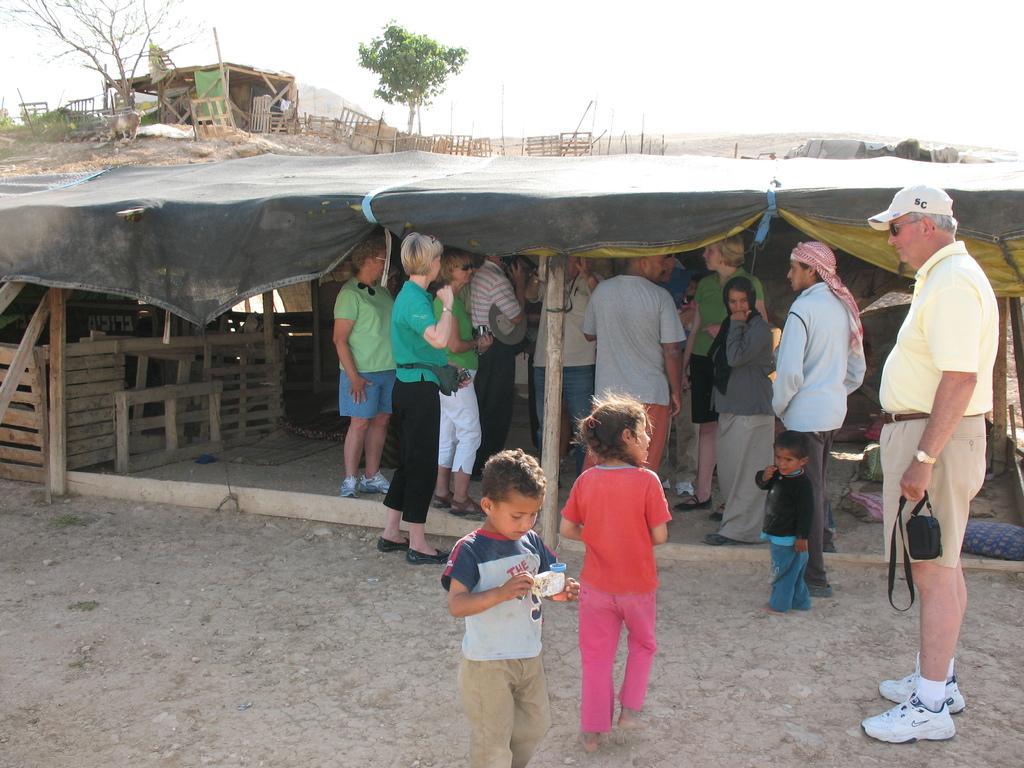In one or two sentences, can you explain what this image depicts? In this image few persons are standing under the tent. Few persons are standing on the land. Right side there is a person wearing a cap is standing on the land. He is holding an object in his hand. Bottom of the image there is a kid holding an object. Beside there is a girl walking on the land. A kid is standing beside the person. He is wearing a cloth on his head. Left side few wooden plants are under the tent. Left side there is a house. Before it there is fence. There are few trees. Behind there is a hill. Top of the image there is sky. 